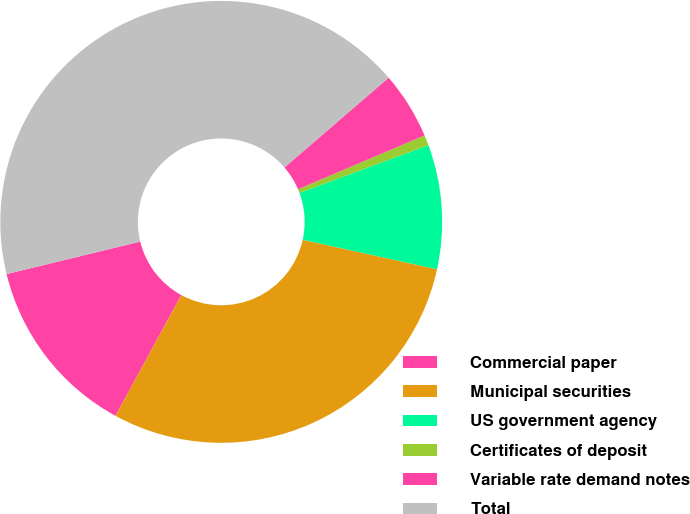Convert chart. <chart><loc_0><loc_0><loc_500><loc_500><pie_chart><fcel>Commercial paper<fcel>Municipal securities<fcel>US government agency<fcel>Certificates of deposit<fcel>Variable rate demand notes<fcel>Total<nl><fcel>13.26%<fcel>29.5%<fcel>9.09%<fcel>0.75%<fcel>4.92%<fcel>42.48%<nl></chart> 